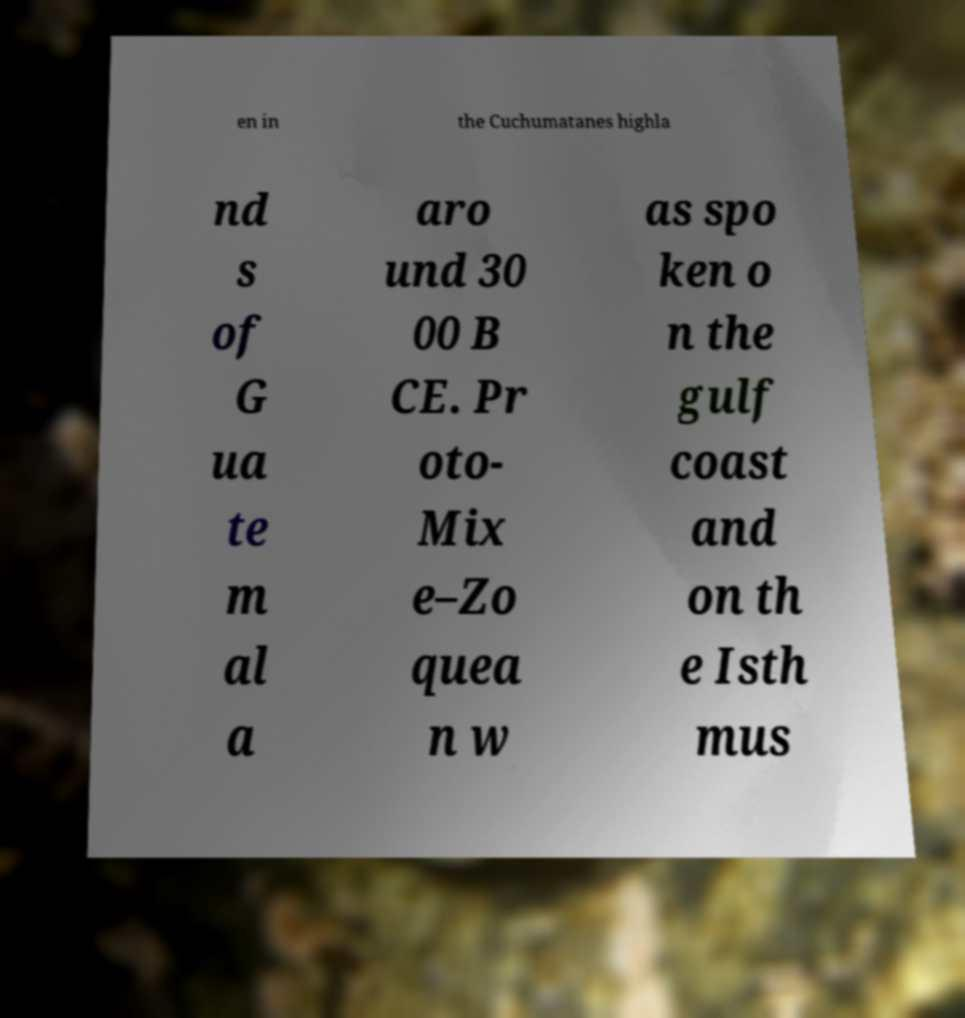Please identify and transcribe the text found in this image. en in the Cuchumatanes highla nd s of G ua te m al a aro und 30 00 B CE. Pr oto- Mix e–Zo quea n w as spo ken o n the gulf coast and on th e Isth mus 